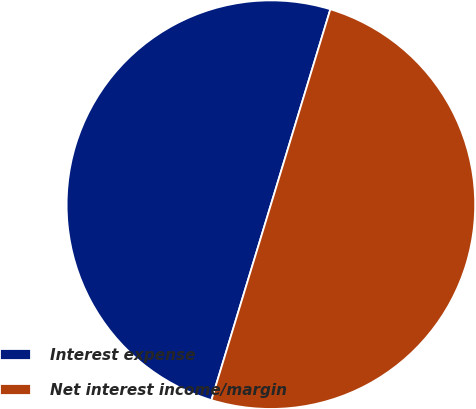Convert chart to OTSL. <chart><loc_0><loc_0><loc_500><loc_500><pie_chart><fcel>Interest expense<fcel>Net interest income/margin<nl><fcel>50.0%<fcel>50.0%<nl></chart> 